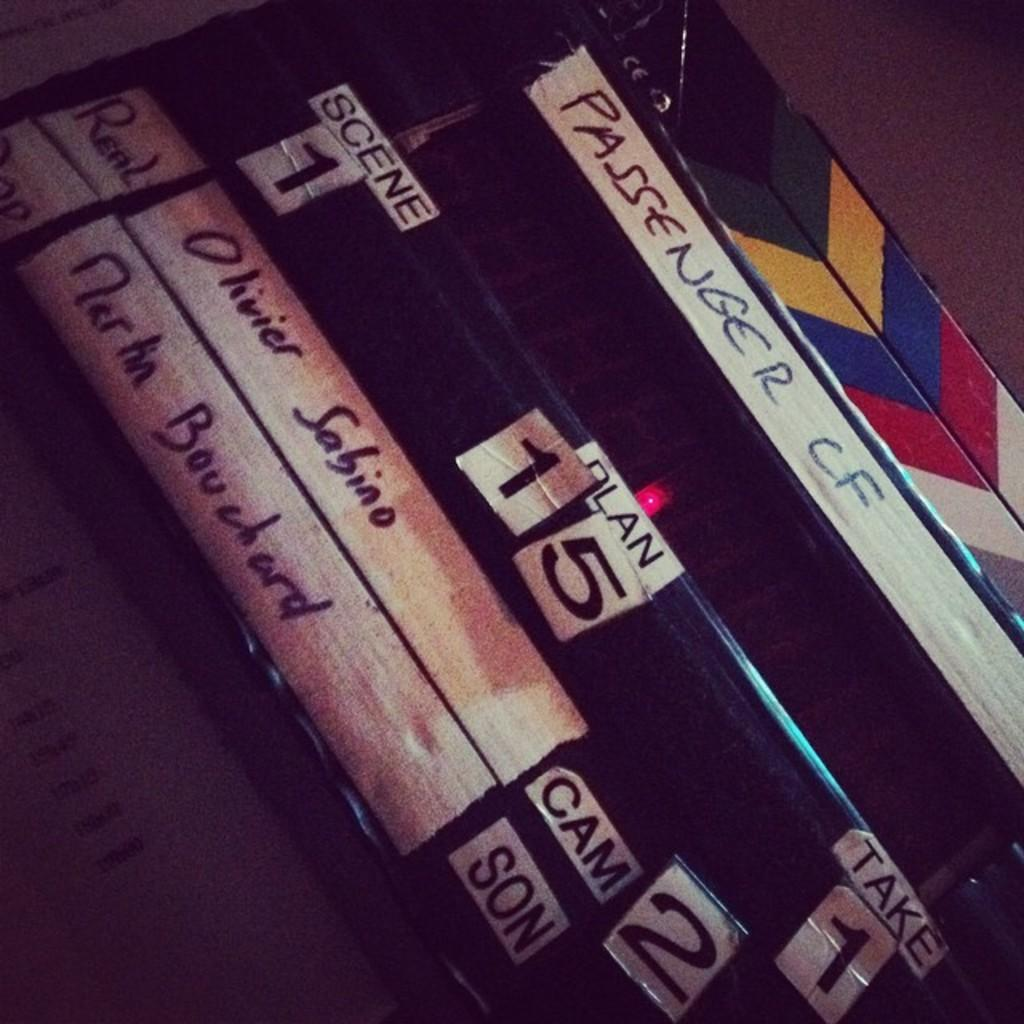<image>
Create a compact narrative representing the image presented. A collection of video includes the label PASSENGER CF. 